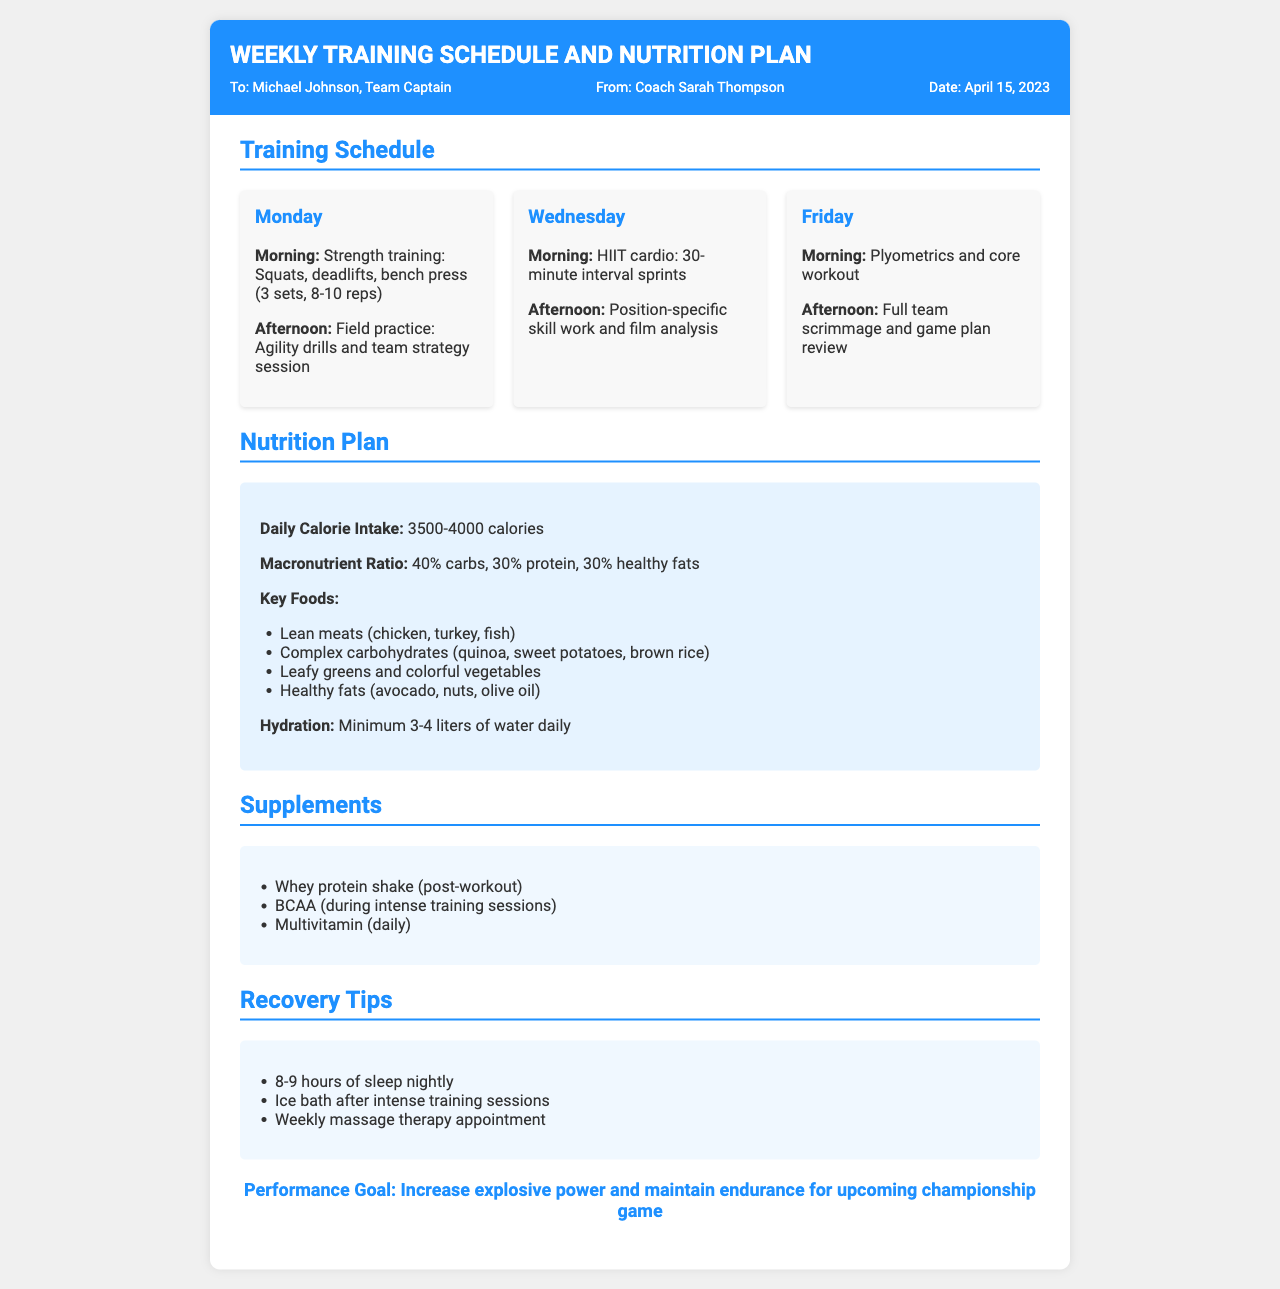what is the date of the fax? The date mentioned in the fax is April 15, 2023.
Answer: April 15, 2023 who is the recipient of the fax? The fax is addressed to Michael Johnson, Team Captain.
Answer: Michael Johnson what is the morning workout routine for Monday? The morning workout routine for Monday includes strength training composed of squats, deadlifts, and bench press (3 sets, 8-10 reps).
Answer: Strength training: Squats, deadlifts, bench press (3 sets, 8-10 reps) how many calories should be consumed daily according to the nutrition plan? The nutrition plan suggests a daily calorie intake of 3500-4000 calories.
Answer: 3500-4000 calories what is the macronutrient ratio recommended in the nutrition plan? The recommended macronutrient ratio in the nutrition plan is 40% carbs, 30% protein, and 30% healthy fats.
Answer: 40% carbs, 30% protein, 30% healthy fats how many liters of water should be consumed daily? The nutrition plan specifies a minimum of 3-4 liters of water daily.
Answer: 3-4 liters what is one key food listed in the nutrition plan? The nutrition plan includes several key foods, such as lean meats, complex carbohydrates, leafy greens, and healthy fats.
Answer: Lean meats (chicken, turkey, fish) what is a recovery tip mentioned in the document? One recovery tip included in the document is to have 8-9 hours of sleep nightly.
Answer: 8-9 hours of sleep nightly what is the performance goal outlined in the fax? The performance goal mentioned in the fax is to increase explosive power and maintain endurance for the upcoming championship game.
Answer: Increase explosive power and maintain endurance for upcoming championship game 